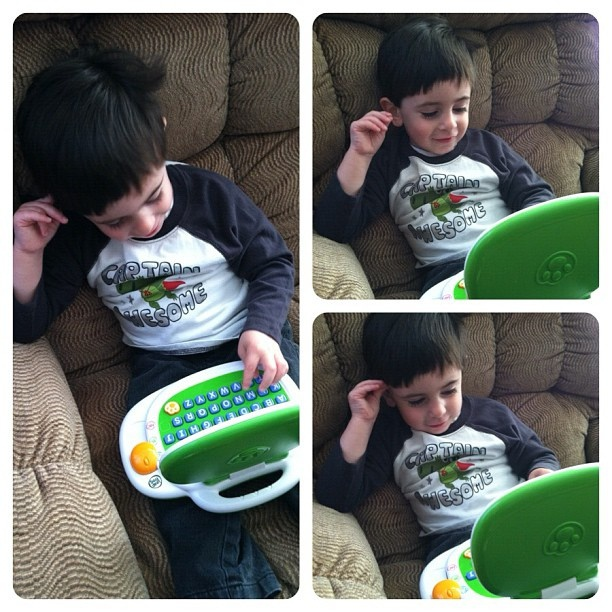Describe the objects in this image and their specific colors. I can see people in white, black, gray, and darkgreen tones, couch in white, black, gray, and darkgray tones, people in white, black, gray, and darkgray tones, couch in white, black, gray, and darkgray tones, and people in white, black, gray, darkgray, and lightgray tones in this image. 